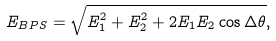Convert formula to latex. <formula><loc_0><loc_0><loc_500><loc_500>E _ { B P S } = \sqrt { E _ { 1 } ^ { 2 } + E _ { 2 } ^ { 2 } + 2 E _ { 1 } E _ { 2 } \cos \Delta \theta } ,</formula> 